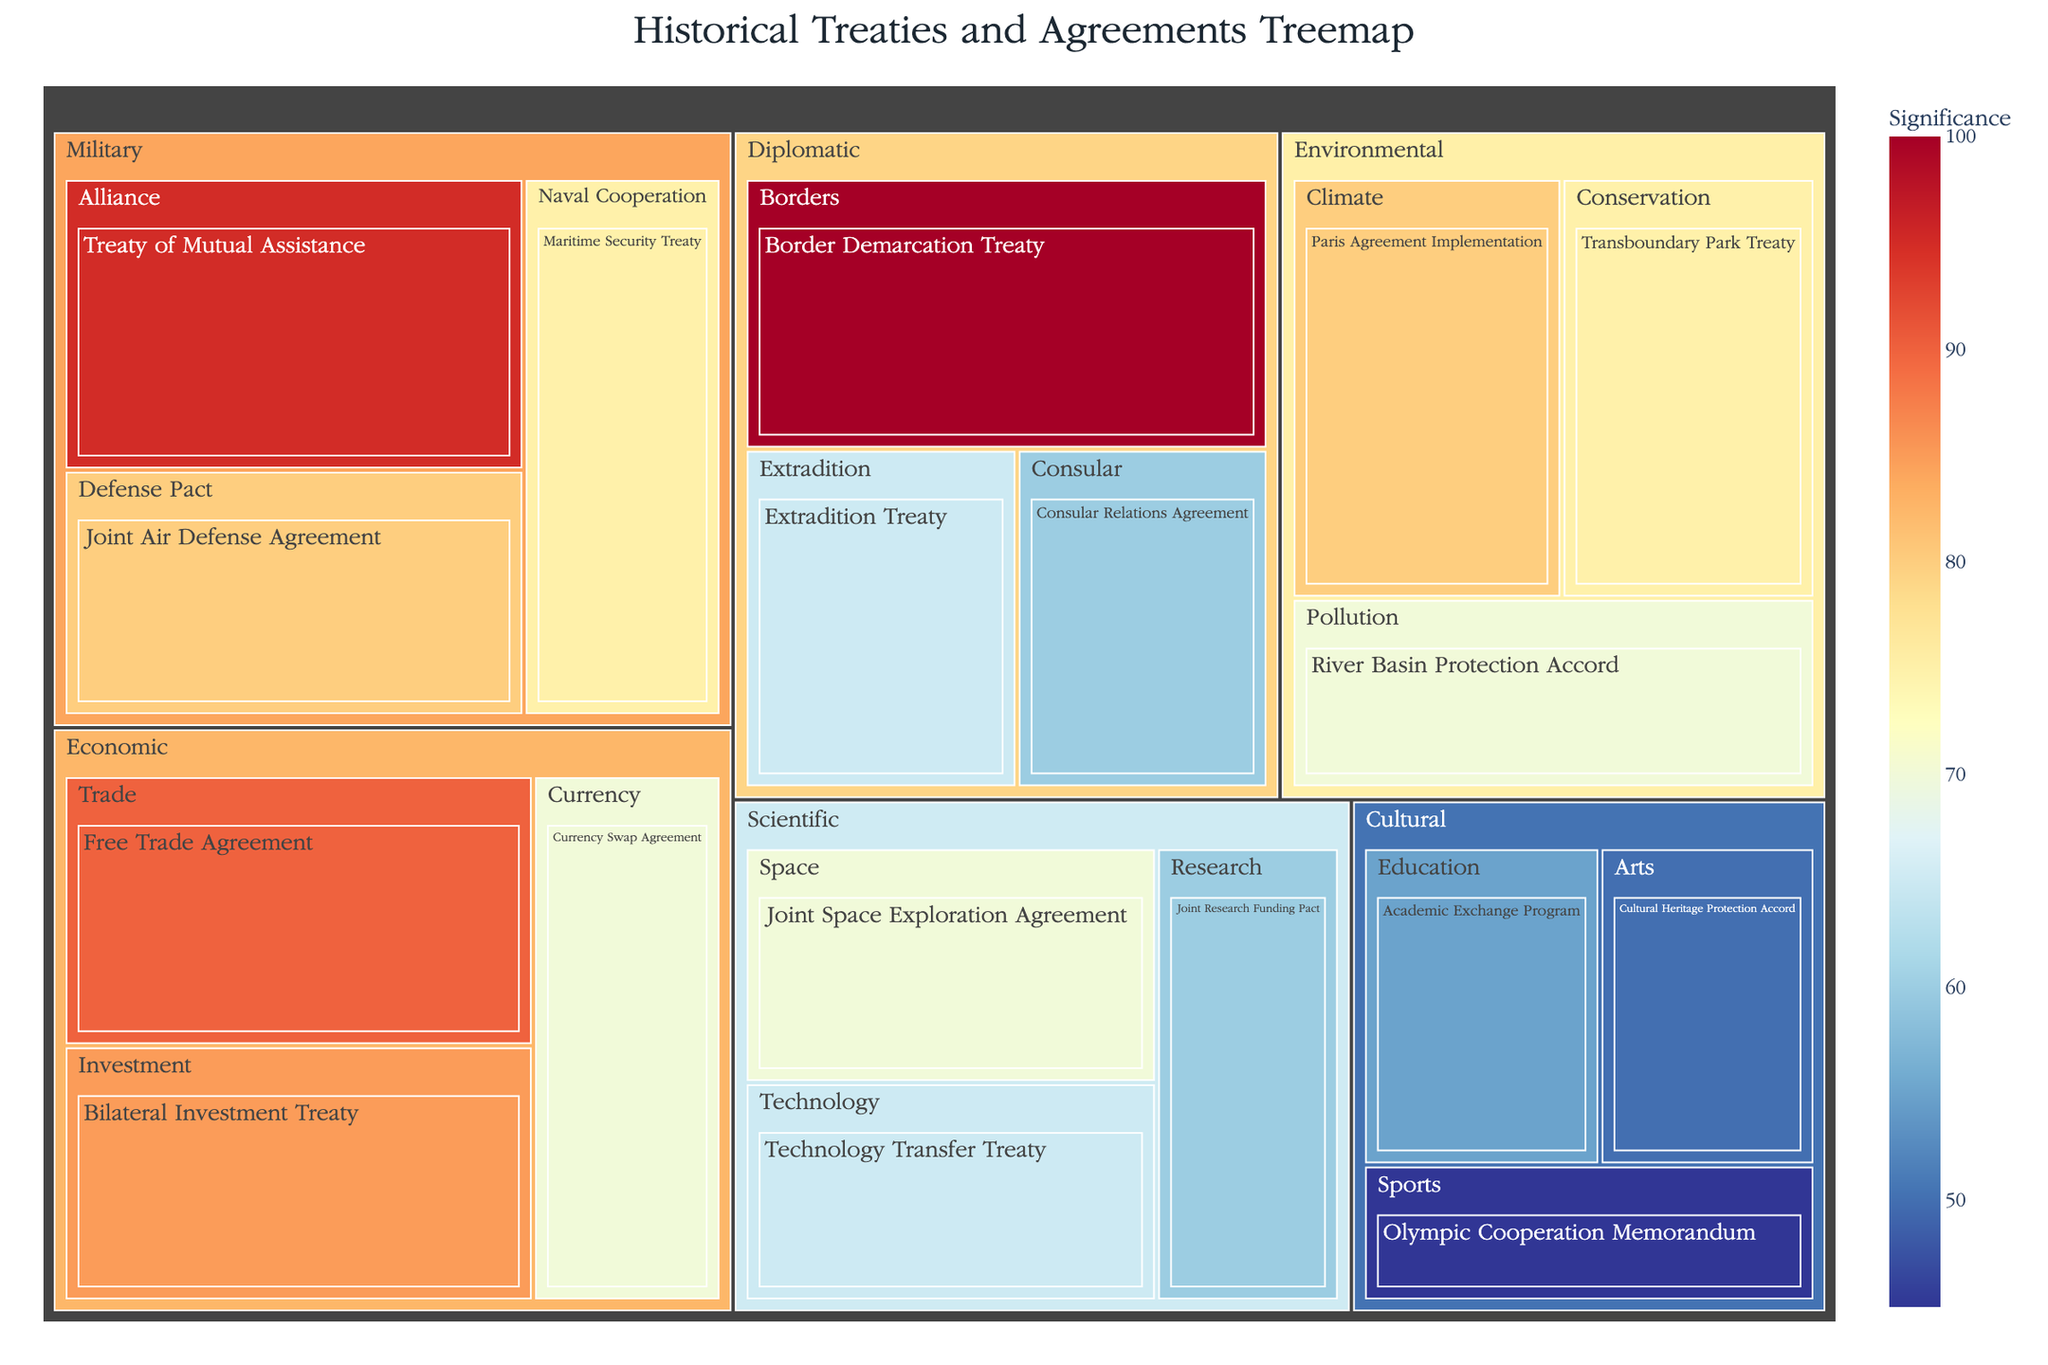What is the title of the figure? The title is located at the top of the figure and is typically formatted in bold or larger font. The title summarizes the content of the figure.
Answer: Historical Treaties and Agreements Treemap Which treaty has the highest significance? Look for the box with the highest value in the figure, as it represents the treaty with the highest significance. It is usually highlighted in the color gradient accordingly.
Answer: Border Demarcation Treaty How many agreements are there in the "Economic" category, and what are their types? Locate the "Economic" category in the treemap, then count the number of distinct boxes representing agreements within this category, and identify each type.
Answer: 3 (Free Trade Agreement, Bilateral Investment Treaty, Currency Swap Agreement) What is the combined significance of all "Environmental" agreements? For each agreement in the "Environmental" category, add their significance values together. The values are provided in the figure.
Answer: 225 Which type of agreement within the "Diplomatic" category has the lowest significance, and what is its value? Locate the "Diplomatic" category and compare the significance values of the agreements within this category to find the lowest one.
Answer: Consular Relations Agreement, 60 Compare the significance of the "Free Trade Agreement" and the "Joint Space Exploration Agreement." Which is higher and by how much? Identify the significance values of both agreements and subtract the smaller value from the larger one. The values are visibly provided.
Answer: Free Trade Agreement is higher by 20 What is the significance rating of the "Maritime Security Treaty"? Find the "Maritime Security Treaty" within the treemap and read its significance value from the figure.
Answer: 75 How many categories have at least one agreement with a significance of 90 or higher? Check each category to see if any agreement within it has a significance value of 90 or more and count those categories.
Answer: 3 (Military, Economic, Diplomatic) Which agreement has the same significance value as the "Currency Swap Agreement"? Find the "Currency Swap Agreement" and note its significance value, then locate any other agreements with the same value by observing the significance labels.
Answer: Joint Space Exploration Agreement (70) In terms of significance, how does the "Transboundary Park Treaty" compare to the "Technology Transfer Treaty"? Compare the significance values of both treaties directly by observing their stated values in the figure.
Answer: Transboundary Park Treaty is higher by 10 